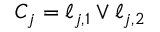<formula> <loc_0><loc_0><loc_500><loc_500>C _ { j } = \ell _ { j , 1 } \vee \ell _ { j , 2 }</formula> 